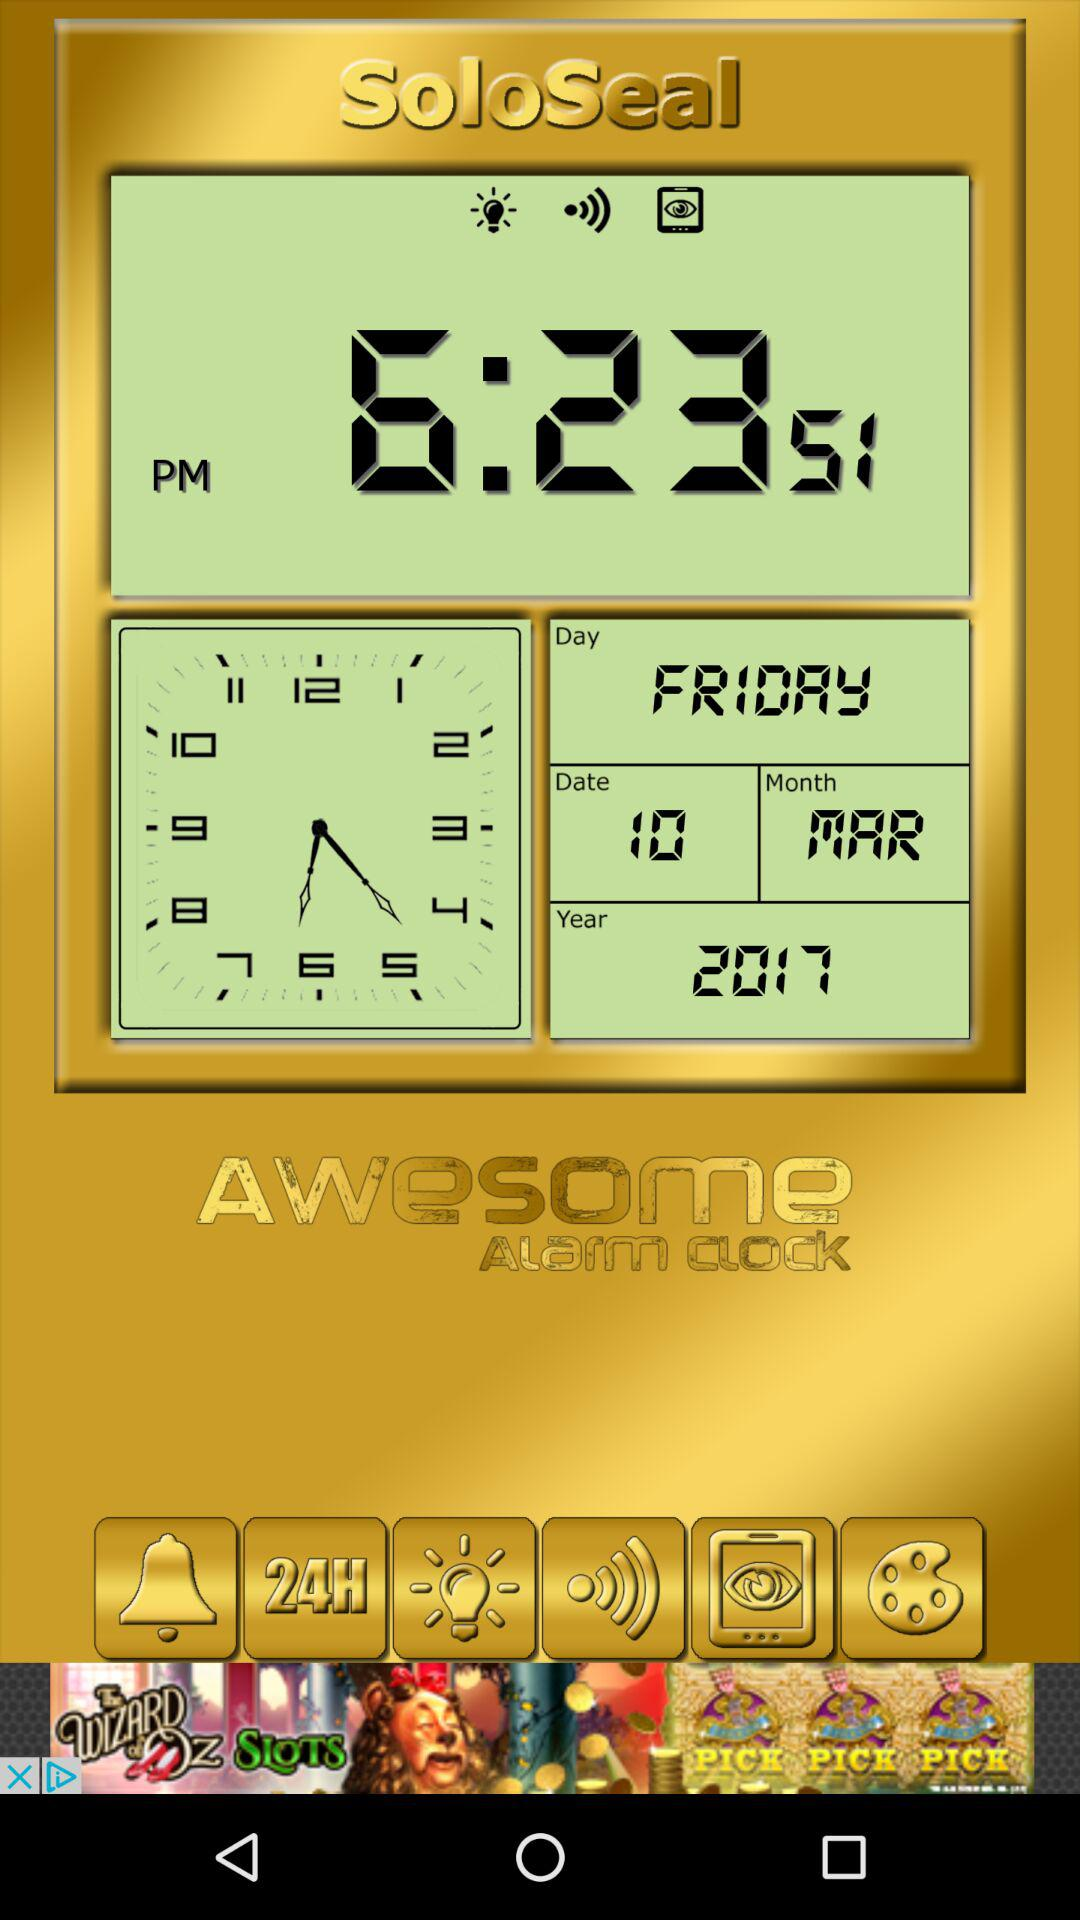What is the day on 10 March 2017? The day is Friday. 